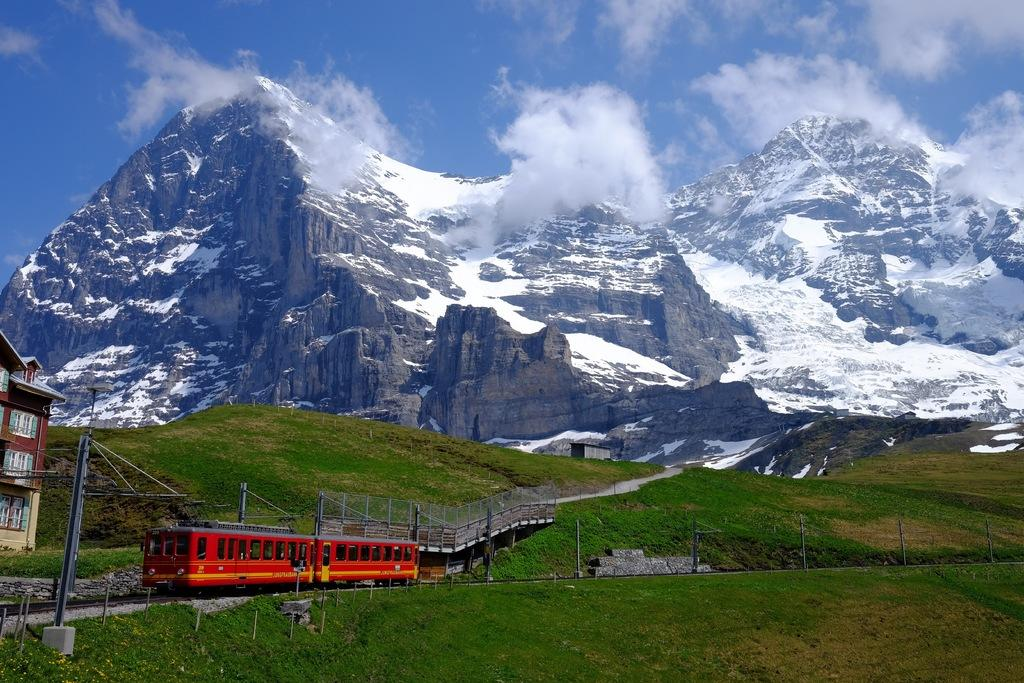What type of natural formations can be seen in the image? There are mountains and a hill in the image. What type of man-made structure is present in the image? There is a building in the image. What type of barrier can be seen in the image? There is a fence in the image. What type of path is visible in the image? There is a path in the image. What type of support structures are present in the image? There are poles and wires in the image. What is visible in the sky in the image? The sky is visible in the image, and there are clouds in the sky. What type of transportation can be seen in the image? There is a train passing on a railway track in the image. What type of industry can be seen in the image? There is no industry present in the image. Is there any quicksand visible in the image? There is no quicksand present in the image. 